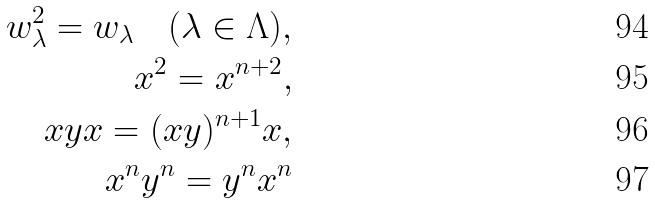<formula> <loc_0><loc_0><loc_500><loc_500>w _ { \lambda } ^ { 2 } = w _ { \lambda } \quad ( \lambda \in \Lambda ) , \\ x ^ { 2 } = x ^ { n + 2 } , \\ x y x = ( x y ) ^ { n + 1 } x , \\ x ^ { n } y ^ { n } = y ^ { n } x ^ { n }</formula> 